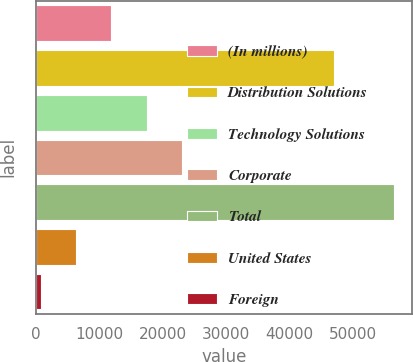Convert chart to OTSL. <chart><loc_0><loc_0><loc_500><loc_500><bar_chart><fcel>(In millions)<fcel>Distribution Solutions<fcel>Technology Solutions<fcel>Corporate<fcel>Total<fcel>United States<fcel>Foreign<nl><fcel>11927<fcel>47088<fcel>17501.5<fcel>23076<fcel>56523<fcel>6352.5<fcel>778<nl></chart> 